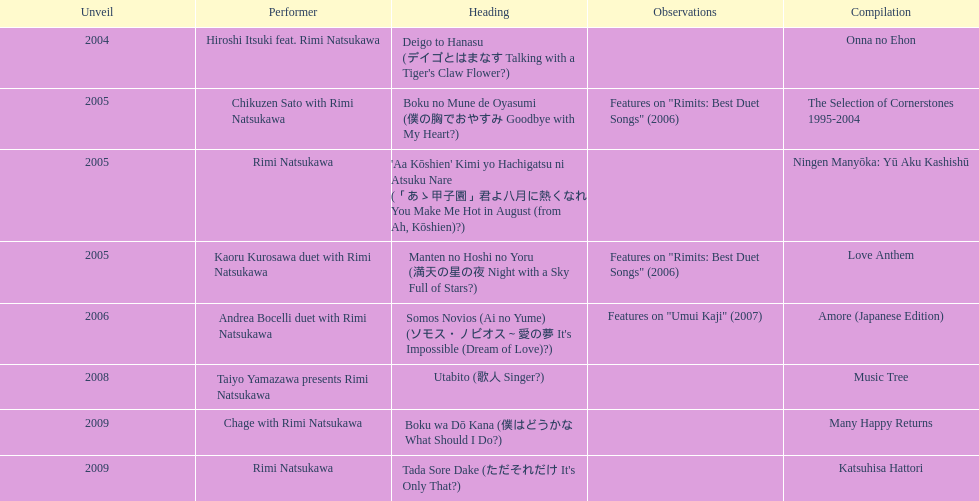Which was released earlier, deigo to hanasu or utabito? Deigo to Hanasu. 